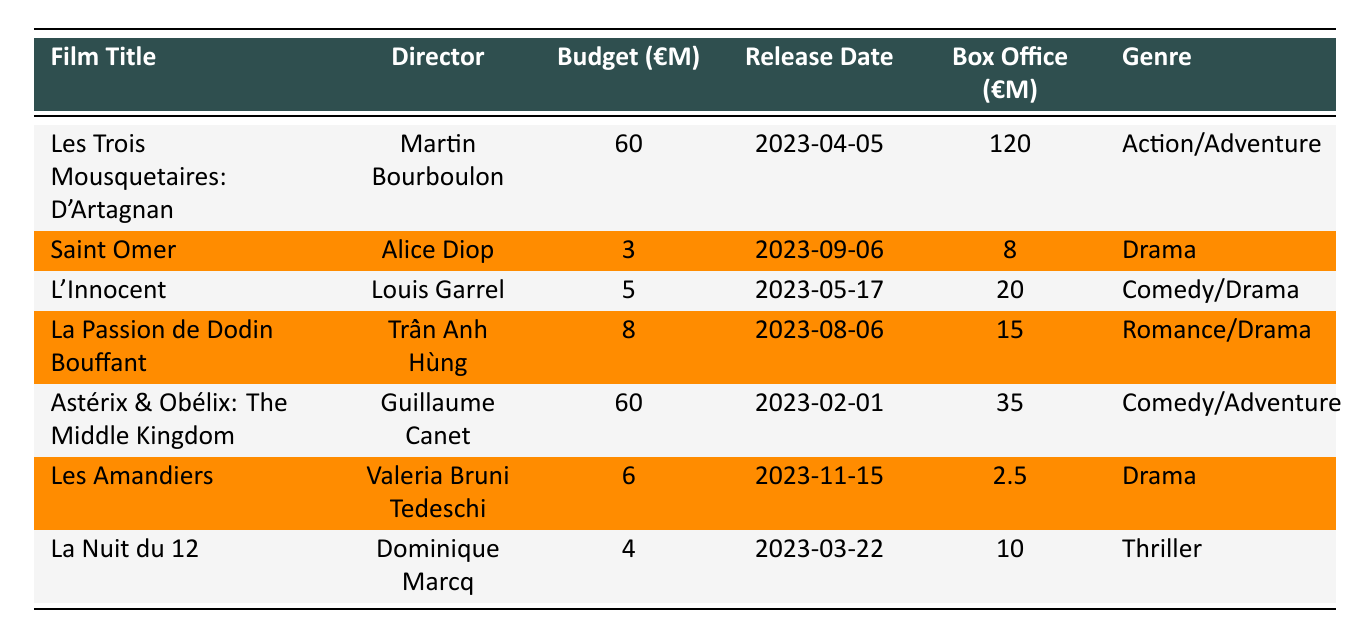What is the production budget of "Saint Omer"? The production budget is listed directly in the table under "Budget (€M)" for "Saint Omer". It shows a value of 3 million euros.
Answer: 3 million euros Which film had the highest box office earnings? By scanning through the "Box Office (€M)" column, "Les Trois Mousquetaires: D'Artagnan" has the highest figure of 120 million euros.
Answer: 120 million euros What is the average production budget of the films listed? The total production budget sums up to (60 + 3 + 5 + 8 + 60 + 6 + 4) = 146 million euros. There are 7 films, so the average is calculated as 146/7 = approximately 20.86 million euros.
Answer: Approximately 20.86 million euros Did "Astérix & Obélix: The Middle Kingdom" perform better at the box office compared to its budget? To determine this, compare the box office (35 million euros) to the budget (60 million euros). Since 35 million is less than 60 million, it did not perform better.
Answer: No How much more did "Les Trois Mousquetaires: D'Artagnan" earn at the box office compared to "La Nuit du 12"? The box office earnings are 120 million euros for "Les Trois Mousquetaires: D'Artagnan" and 10 million euros for "La Nuit du 12". The difference is 120 - 10 = 110 million euros.
Answer: 110 million euros Which genres had films with production budgets under 10 million euros? By examining the "Budget (€M)" column, "Saint Omer", "L'Innocent", "La Passion de Dodin Bouffant", "Les Amandiers", and "La Nuit du 12" all have budgets under 10 million euros. Their genres are Drama, Comedy/Drama, Romance/Drama, Drama, and Thriller, respectively.
Answer: Drama, Comedy/Drama, Romance/Drama, Thriller What percentage of their production budget did "L'Innocent" recoup from its box office? The production budget for "L'Innocent" is 5 million euros and its box office is 20 million euros. To find the percentage recouped, (20/5) * 100 = 400%.
Answer: 400% Which director had the lowest budget for their film and what was the amount? Scanning through the budgets, "Alice Diop" directed "Saint Omer" which had the lowest budget of 3 million euros.
Answer: Alice Diop; 3 million euros Did both "Les Amandiers" and "La Nuit du 12" make a profit? Both films would need to have box office figures higher than their respective production budgets to be deemed profitable. "Les Amandiers" earned 2.5 million with a budget of 6 million, and "La Nuit du 12" earned 10 million with a budget of 4 million. This makes "Les Amandiers" a loss while "La Nuit du 12" made a profit.
Answer: No, only "La Nuit du 12" made a profit 